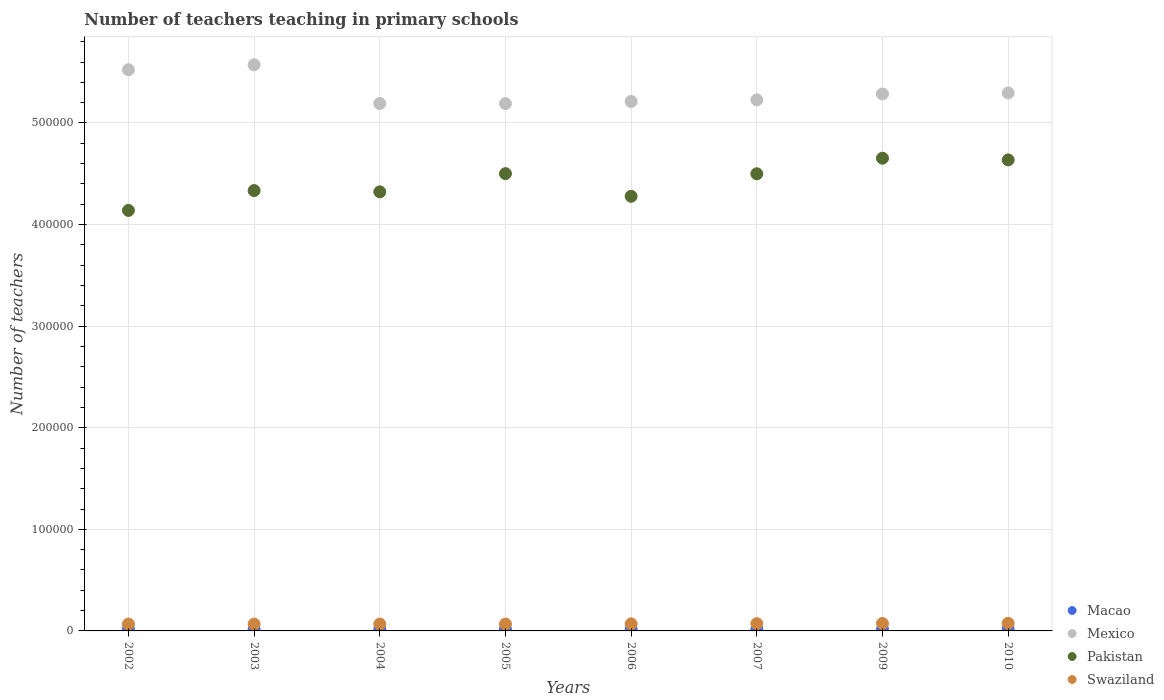How many different coloured dotlines are there?
Offer a terse response. 4. What is the number of teachers teaching in primary schools in Swaziland in 2004?
Provide a succinct answer. 6758. Across all years, what is the maximum number of teachers teaching in primary schools in Pakistan?
Your response must be concise. 4.65e+05. Across all years, what is the minimum number of teachers teaching in primary schools in Mexico?
Provide a short and direct response. 5.19e+05. In which year was the number of teachers teaching in primary schools in Mexico minimum?
Provide a short and direct response. 2005. What is the total number of teachers teaching in primary schools in Swaziland in the graph?
Your response must be concise. 5.58e+04. What is the difference between the number of teachers teaching in primary schools in Macao in 2002 and that in 2006?
Provide a succinct answer. -1. What is the difference between the number of teachers teaching in primary schools in Swaziland in 2006 and the number of teachers teaching in primary schools in Mexico in 2010?
Make the answer very short. -5.23e+05. What is the average number of teachers teaching in primary schools in Swaziland per year?
Provide a short and direct response. 6969.25. In the year 2007, what is the difference between the number of teachers teaching in primary schools in Macao and number of teachers teaching in primary schools in Swaziland?
Provide a short and direct response. -5551. What is the ratio of the number of teachers teaching in primary schools in Swaziland in 2004 to that in 2006?
Ensure brevity in your answer.  0.98. Is the number of teachers teaching in primary schools in Swaziland in 2003 less than that in 2006?
Your response must be concise. Yes. Is the difference between the number of teachers teaching in primary schools in Macao in 2005 and 2007 greater than the difference between the number of teachers teaching in primary schools in Swaziland in 2005 and 2007?
Your answer should be compact. Yes. What is the difference between the highest and the second highest number of teachers teaching in primary schools in Swaziland?
Offer a terse response. 153. What is the difference between the highest and the lowest number of teachers teaching in primary schools in Pakistan?
Keep it short and to the point. 5.14e+04. Is the sum of the number of teachers teaching in primary schools in Pakistan in 2005 and 2007 greater than the maximum number of teachers teaching in primary schools in Macao across all years?
Give a very brief answer. Yes. Is it the case that in every year, the sum of the number of teachers teaching in primary schools in Macao and number of teachers teaching in primary schools in Swaziland  is greater than the sum of number of teachers teaching in primary schools in Mexico and number of teachers teaching in primary schools in Pakistan?
Your answer should be very brief. No. Is it the case that in every year, the sum of the number of teachers teaching in primary schools in Pakistan and number of teachers teaching in primary schools in Mexico  is greater than the number of teachers teaching in primary schools in Swaziland?
Your response must be concise. Yes. Does the number of teachers teaching in primary schools in Mexico monotonically increase over the years?
Your response must be concise. No. Is the number of teachers teaching in primary schools in Pakistan strictly less than the number of teachers teaching in primary schools in Swaziland over the years?
Offer a terse response. No. How many dotlines are there?
Provide a short and direct response. 4. What is the difference between two consecutive major ticks on the Y-axis?
Give a very brief answer. 1.00e+05. Does the graph contain any zero values?
Provide a succinct answer. No. How are the legend labels stacked?
Ensure brevity in your answer.  Vertical. What is the title of the graph?
Provide a succinct answer. Number of teachers teaching in primary schools. Does "Japan" appear as one of the legend labels in the graph?
Your answer should be very brief. No. What is the label or title of the X-axis?
Provide a short and direct response. Years. What is the label or title of the Y-axis?
Make the answer very short. Number of teachers. What is the Number of teachers of Macao in 2002?
Your answer should be very brief. 1616. What is the Number of teachers in Mexico in 2002?
Keep it short and to the point. 5.52e+05. What is the Number of teachers of Pakistan in 2002?
Your answer should be very brief. 4.14e+05. What is the Number of teachers in Swaziland in 2002?
Ensure brevity in your answer.  6727. What is the Number of teachers in Macao in 2003?
Offer a terse response. 1615. What is the Number of teachers in Mexico in 2003?
Offer a very short reply. 5.57e+05. What is the Number of teachers in Pakistan in 2003?
Your answer should be compact. 4.33e+05. What is the Number of teachers in Swaziland in 2003?
Make the answer very short. 6680. What is the Number of teachers of Macao in 2004?
Keep it short and to the point. 1632. What is the Number of teachers in Mexico in 2004?
Offer a terse response. 5.19e+05. What is the Number of teachers of Pakistan in 2004?
Give a very brief answer. 4.32e+05. What is the Number of teachers of Swaziland in 2004?
Your answer should be compact. 6758. What is the Number of teachers in Macao in 2005?
Give a very brief answer. 1609. What is the Number of teachers of Mexico in 2005?
Offer a very short reply. 5.19e+05. What is the Number of teachers in Pakistan in 2005?
Give a very brief answer. 4.50e+05. What is the Number of teachers of Swaziland in 2005?
Provide a short and direct response. 6741. What is the Number of teachers of Macao in 2006?
Offer a very short reply. 1617. What is the Number of teachers in Mexico in 2006?
Offer a terse response. 5.21e+05. What is the Number of teachers in Pakistan in 2006?
Offer a terse response. 4.28e+05. What is the Number of teachers in Swaziland in 2006?
Ensure brevity in your answer.  6906. What is the Number of teachers of Macao in 2007?
Offer a very short reply. 1618. What is the Number of teachers of Mexico in 2007?
Ensure brevity in your answer.  5.23e+05. What is the Number of teachers in Pakistan in 2007?
Your response must be concise. 4.50e+05. What is the Number of teachers of Swaziland in 2007?
Ensure brevity in your answer.  7169. What is the Number of teachers of Macao in 2009?
Your answer should be very brief. 1585. What is the Number of teachers of Mexico in 2009?
Make the answer very short. 5.29e+05. What is the Number of teachers of Pakistan in 2009?
Keep it short and to the point. 4.65e+05. What is the Number of teachers of Swaziland in 2009?
Ensure brevity in your answer.  7310. What is the Number of teachers of Macao in 2010?
Keep it short and to the point. 1577. What is the Number of teachers in Mexico in 2010?
Your answer should be compact. 5.30e+05. What is the Number of teachers of Pakistan in 2010?
Keep it short and to the point. 4.64e+05. What is the Number of teachers in Swaziland in 2010?
Provide a succinct answer. 7463. Across all years, what is the maximum Number of teachers of Macao?
Offer a terse response. 1632. Across all years, what is the maximum Number of teachers in Mexico?
Offer a terse response. 5.57e+05. Across all years, what is the maximum Number of teachers of Pakistan?
Your answer should be very brief. 4.65e+05. Across all years, what is the maximum Number of teachers of Swaziland?
Your answer should be compact. 7463. Across all years, what is the minimum Number of teachers in Macao?
Provide a succinct answer. 1577. Across all years, what is the minimum Number of teachers in Mexico?
Offer a very short reply. 5.19e+05. Across all years, what is the minimum Number of teachers in Pakistan?
Provide a succinct answer. 4.14e+05. Across all years, what is the minimum Number of teachers of Swaziland?
Offer a terse response. 6680. What is the total Number of teachers in Macao in the graph?
Ensure brevity in your answer.  1.29e+04. What is the total Number of teachers of Mexico in the graph?
Your answer should be compact. 4.25e+06. What is the total Number of teachers of Pakistan in the graph?
Your response must be concise. 3.54e+06. What is the total Number of teachers of Swaziland in the graph?
Offer a terse response. 5.58e+04. What is the difference between the Number of teachers in Macao in 2002 and that in 2003?
Your response must be concise. 1. What is the difference between the Number of teachers in Mexico in 2002 and that in 2003?
Your answer should be very brief. -4869. What is the difference between the Number of teachers in Pakistan in 2002 and that in 2003?
Make the answer very short. -1.95e+04. What is the difference between the Number of teachers in Mexico in 2002 and that in 2004?
Offer a very short reply. 3.32e+04. What is the difference between the Number of teachers of Pakistan in 2002 and that in 2004?
Ensure brevity in your answer.  -1.83e+04. What is the difference between the Number of teachers of Swaziland in 2002 and that in 2004?
Your answer should be very brief. -31. What is the difference between the Number of teachers in Macao in 2002 and that in 2005?
Provide a short and direct response. 7. What is the difference between the Number of teachers in Mexico in 2002 and that in 2005?
Keep it short and to the point. 3.33e+04. What is the difference between the Number of teachers of Pakistan in 2002 and that in 2005?
Give a very brief answer. -3.62e+04. What is the difference between the Number of teachers in Mexico in 2002 and that in 2006?
Your answer should be compact. 3.12e+04. What is the difference between the Number of teachers of Pakistan in 2002 and that in 2006?
Make the answer very short. -1.39e+04. What is the difference between the Number of teachers in Swaziland in 2002 and that in 2006?
Ensure brevity in your answer.  -179. What is the difference between the Number of teachers in Mexico in 2002 and that in 2007?
Provide a short and direct response. 2.97e+04. What is the difference between the Number of teachers of Pakistan in 2002 and that in 2007?
Offer a very short reply. -3.61e+04. What is the difference between the Number of teachers of Swaziland in 2002 and that in 2007?
Ensure brevity in your answer.  -442. What is the difference between the Number of teachers of Mexico in 2002 and that in 2009?
Your answer should be very brief. 2.39e+04. What is the difference between the Number of teachers in Pakistan in 2002 and that in 2009?
Give a very brief answer. -5.14e+04. What is the difference between the Number of teachers in Swaziland in 2002 and that in 2009?
Offer a very short reply. -583. What is the difference between the Number of teachers in Macao in 2002 and that in 2010?
Your answer should be compact. 39. What is the difference between the Number of teachers of Mexico in 2002 and that in 2010?
Your answer should be very brief. 2.28e+04. What is the difference between the Number of teachers of Pakistan in 2002 and that in 2010?
Provide a short and direct response. -4.98e+04. What is the difference between the Number of teachers of Swaziland in 2002 and that in 2010?
Your answer should be very brief. -736. What is the difference between the Number of teachers of Mexico in 2003 and that in 2004?
Offer a terse response. 3.81e+04. What is the difference between the Number of teachers in Pakistan in 2003 and that in 2004?
Provide a succinct answer. 1239. What is the difference between the Number of teachers of Swaziland in 2003 and that in 2004?
Offer a terse response. -78. What is the difference between the Number of teachers of Macao in 2003 and that in 2005?
Your answer should be compact. 6. What is the difference between the Number of teachers of Mexico in 2003 and that in 2005?
Ensure brevity in your answer.  3.82e+04. What is the difference between the Number of teachers in Pakistan in 2003 and that in 2005?
Provide a short and direct response. -1.67e+04. What is the difference between the Number of teachers in Swaziland in 2003 and that in 2005?
Give a very brief answer. -61. What is the difference between the Number of teachers in Macao in 2003 and that in 2006?
Give a very brief answer. -2. What is the difference between the Number of teachers of Mexico in 2003 and that in 2006?
Your answer should be very brief. 3.61e+04. What is the difference between the Number of teachers in Pakistan in 2003 and that in 2006?
Make the answer very short. 5631. What is the difference between the Number of teachers of Swaziland in 2003 and that in 2006?
Your response must be concise. -226. What is the difference between the Number of teachers in Macao in 2003 and that in 2007?
Your response must be concise. -3. What is the difference between the Number of teachers in Mexico in 2003 and that in 2007?
Provide a short and direct response. 3.45e+04. What is the difference between the Number of teachers of Pakistan in 2003 and that in 2007?
Offer a very short reply. -1.66e+04. What is the difference between the Number of teachers in Swaziland in 2003 and that in 2007?
Your response must be concise. -489. What is the difference between the Number of teachers of Macao in 2003 and that in 2009?
Give a very brief answer. 30. What is the difference between the Number of teachers of Mexico in 2003 and that in 2009?
Provide a succinct answer. 2.87e+04. What is the difference between the Number of teachers in Pakistan in 2003 and that in 2009?
Your response must be concise. -3.19e+04. What is the difference between the Number of teachers in Swaziland in 2003 and that in 2009?
Ensure brevity in your answer.  -630. What is the difference between the Number of teachers in Mexico in 2003 and that in 2010?
Provide a short and direct response. 2.77e+04. What is the difference between the Number of teachers of Pakistan in 2003 and that in 2010?
Offer a very short reply. -3.02e+04. What is the difference between the Number of teachers in Swaziland in 2003 and that in 2010?
Offer a very short reply. -783. What is the difference between the Number of teachers in Macao in 2004 and that in 2005?
Keep it short and to the point. 23. What is the difference between the Number of teachers of Mexico in 2004 and that in 2005?
Provide a short and direct response. 49. What is the difference between the Number of teachers in Pakistan in 2004 and that in 2005?
Keep it short and to the point. -1.79e+04. What is the difference between the Number of teachers of Swaziland in 2004 and that in 2005?
Offer a terse response. 17. What is the difference between the Number of teachers in Macao in 2004 and that in 2006?
Your response must be concise. 15. What is the difference between the Number of teachers of Mexico in 2004 and that in 2006?
Offer a very short reply. -2022. What is the difference between the Number of teachers of Pakistan in 2004 and that in 2006?
Your answer should be very brief. 4392. What is the difference between the Number of teachers of Swaziland in 2004 and that in 2006?
Give a very brief answer. -148. What is the difference between the Number of teachers of Macao in 2004 and that in 2007?
Your answer should be very brief. 14. What is the difference between the Number of teachers of Mexico in 2004 and that in 2007?
Make the answer very short. -3572. What is the difference between the Number of teachers in Pakistan in 2004 and that in 2007?
Your answer should be compact. -1.78e+04. What is the difference between the Number of teachers in Swaziland in 2004 and that in 2007?
Provide a succinct answer. -411. What is the difference between the Number of teachers in Mexico in 2004 and that in 2009?
Make the answer very short. -9394. What is the difference between the Number of teachers in Pakistan in 2004 and that in 2009?
Your response must be concise. -3.31e+04. What is the difference between the Number of teachers in Swaziland in 2004 and that in 2009?
Your answer should be compact. -552. What is the difference between the Number of teachers in Mexico in 2004 and that in 2010?
Make the answer very short. -1.04e+04. What is the difference between the Number of teachers in Pakistan in 2004 and that in 2010?
Offer a very short reply. -3.15e+04. What is the difference between the Number of teachers in Swaziland in 2004 and that in 2010?
Your answer should be very brief. -705. What is the difference between the Number of teachers of Mexico in 2005 and that in 2006?
Ensure brevity in your answer.  -2071. What is the difference between the Number of teachers in Pakistan in 2005 and that in 2006?
Provide a succinct answer. 2.23e+04. What is the difference between the Number of teachers in Swaziland in 2005 and that in 2006?
Your answer should be very brief. -165. What is the difference between the Number of teachers of Mexico in 2005 and that in 2007?
Your answer should be very brief. -3621. What is the difference between the Number of teachers in Pakistan in 2005 and that in 2007?
Provide a short and direct response. 109. What is the difference between the Number of teachers in Swaziland in 2005 and that in 2007?
Offer a terse response. -428. What is the difference between the Number of teachers of Mexico in 2005 and that in 2009?
Make the answer very short. -9443. What is the difference between the Number of teachers in Pakistan in 2005 and that in 2009?
Your response must be concise. -1.52e+04. What is the difference between the Number of teachers in Swaziland in 2005 and that in 2009?
Your answer should be very brief. -569. What is the difference between the Number of teachers in Mexico in 2005 and that in 2010?
Give a very brief answer. -1.05e+04. What is the difference between the Number of teachers in Pakistan in 2005 and that in 2010?
Your answer should be very brief. -1.35e+04. What is the difference between the Number of teachers in Swaziland in 2005 and that in 2010?
Your answer should be compact. -722. What is the difference between the Number of teachers in Mexico in 2006 and that in 2007?
Provide a succinct answer. -1550. What is the difference between the Number of teachers in Pakistan in 2006 and that in 2007?
Make the answer very short. -2.22e+04. What is the difference between the Number of teachers of Swaziland in 2006 and that in 2007?
Offer a terse response. -263. What is the difference between the Number of teachers of Mexico in 2006 and that in 2009?
Offer a terse response. -7372. What is the difference between the Number of teachers of Pakistan in 2006 and that in 2009?
Provide a succinct answer. -3.75e+04. What is the difference between the Number of teachers of Swaziland in 2006 and that in 2009?
Offer a terse response. -404. What is the difference between the Number of teachers in Macao in 2006 and that in 2010?
Your answer should be very brief. 40. What is the difference between the Number of teachers in Mexico in 2006 and that in 2010?
Your answer should be compact. -8416. What is the difference between the Number of teachers in Pakistan in 2006 and that in 2010?
Ensure brevity in your answer.  -3.58e+04. What is the difference between the Number of teachers of Swaziland in 2006 and that in 2010?
Your response must be concise. -557. What is the difference between the Number of teachers in Macao in 2007 and that in 2009?
Offer a terse response. 33. What is the difference between the Number of teachers of Mexico in 2007 and that in 2009?
Your answer should be compact. -5822. What is the difference between the Number of teachers of Pakistan in 2007 and that in 2009?
Provide a succinct answer. -1.53e+04. What is the difference between the Number of teachers of Swaziland in 2007 and that in 2009?
Ensure brevity in your answer.  -141. What is the difference between the Number of teachers in Macao in 2007 and that in 2010?
Your answer should be compact. 41. What is the difference between the Number of teachers in Mexico in 2007 and that in 2010?
Provide a succinct answer. -6866. What is the difference between the Number of teachers in Pakistan in 2007 and that in 2010?
Offer a terse response. -1.36e+04. What is the difference between the Number of teachers of Swaziland in 2007 and that in 2010?
Provide a short and direct response. -294. What is the difference between the Number of teachers of Macao in 2009 and that in 2010?
Ensure brevity in your answer.  8. What is the difference between the Number of teachers in Mexico in 2009 and that in 2010?
Offer a very short reply. -1044. What is the difference between the Number of teachers in Pakistan in 2009 and that in 2010?
Offer a terse response. 1660. What is the difference between the Number of teachers in Swaziland in 2009 and that in 2010?
Your answer should be compact. -153. What is the difference between the Number of teachers in Macao in 2002 and the Number of teachers in Mexico in 2003?
Provide a succinct answer. -5.56e+05. What is the difference between the Number of teachers of Macao in 2002 and the Number of teachers of Pakistan in 2003?
Ensure brevity in your answer.  -4.32e+05. What is the difference between the Number of teachers in Macao in 2002 and the Number of teachers in Swaziland in 2003?
Make the answer very short. -5064. What is the difference between the Number of teachers of Mexico in 2002 and the Number of teachers of Pakistan in 2003?
Your answer should be compact. 1.19e+05. What is the difference between the Number of teachers of Mexico in 2002 and the Number of teachers of Swaziland in 2003?
Your answer should be very brief. 5.46e+05. What is the difference between the Number of teachers of Pakistan in 2002 and the Number of teachers of Swaziland in 2003?
Your response must be concise. 4.07e+05. What is the difference between the Number of teachers in Macao in 2002 and the Number of teachers in Mexico in 2004?
Your answer should be compact. -5.18e+05. What is the difference between the Number of teachers in Macao in 2002 and the Number of teachers in Pakistan in 2004?
Offer a terse response. -4.31e+05. What is the difference between the Number of teachers in Macao in 2002 and the Number of teachers in Swaziland in 2004?
Make the answer very short. -5142. What is the difference between the Number of teachers of Mexico in 2002 and the Number of teachers of Pakistan in 2004?
Your answer should be very brief. 1.20e+05. What is the difference between the Number of teachers of Mexico in 2002 and the Number of teachers of Swaziland in 2004?
Your answer should be compact. 5.46e+05. What is the difference between the Number of teachers of Pakistan in 2002 and the Number of teachers of Swaziland in 2004?
Your answer should be compact. 4.07e+05. What is the difference between the Number of teachers in Macao in 2002 and the Number of teachers in Mexico in 2005?
Give a very brief answer. -5.17e+05. What is the difference between the Number of teachers in Macao in 2002 and the Number of teachers in Pakistan in 2005?
Your answer should be compact. -4.49e+05. What is the difference between the Number of teachers in Macao in 2002 and the Number of teachers in Swaziland in 2005?
Make the answer very short. -5125. What is the difference between the Number of teachers in Mexico in 2002 and the Number of teachers in Pakistan in 2005?
Your answer should be very brief. 1.02e+05. What is the difference between the Number of teachers in Mexico in 2002 and the Number of teachers in Swaziland in 2005?
Provide a succinct answer. 5.46e+05. What is the difference between the Number of teachers of Pakistan in 2002 and the Number of teachers of Swaziland in 2005?
Your answer should be compact. 4.07e+05. What is the difference between the Number of teachers of Macao in 2002 and the Number of teachers of Mexico in 2006?
Ensure brevity in your answer.  -5.20e+05. What is the difference between the Number of teachers in Macao in 2002 and the Number of teachers in Pakistan in 2006?
Ensure brevity in your answer.  -4.26e+05. What is the difference between the Number of teachers in Macao in 2002 and the Number of teachers in Swaziland in 2006?
Your answer should be very brief. -5290. What is the difference between the Number of teachers of Mexico in 2002 and the Number of teachers of Pakistan in 2006?
Your answer should be compact. 1.25e+05. What is the difference between the Number of teachers in Mexico in 2002 and the Number of teachers in Swaziland in 2006?
Your answer should be very brief. 5.46e+05. What is the difference between the Number of teachers in Pakistan in 2002 and the Number of teachers in Swaziland in 2006?
Provide a succinct answer. 4.07e+05. What is the difference between the Number of teachers in Macao in 2002 and the Number of teachers in Mexico in 2007?
Provide a short and direct response. -5.21e+05. What is the difference between the Number of teachers in Macao in 2002 and the Number of teachers in Pakistan in 2007?
Your response must be concise. -4.48e+05. What is the difference between the Number of teachers in Macao in 2002 and the Number of teachers in Swaziland in 2007?
Ensure brevity in your answer.  -5553. What is the difference between the Number of teachers of Mexico in 2002 and the Number of teachers of Pakistan in 2007?
Keep it short and to the point. 1.02e+05. What is the difference between the Number of teachers in Mexico in 2002 and the Number of teachers in Swaziland in 2007?
Offer a very short reply. 5.45e+05. What is the difference between the Number of teachers in Pakistan in 2002 and the Number of teachers in Swaziland in 2007?
Offer a very short reply. 4.07e+05. What is the difference between the Number of teachers in Macao in 2002 and the Number of teachers in Mexico in 2009?
Offer a terse response. -5.27e+05. What is the difference between the Number of teachers of Macao in 2002 and the Number of teachers of Pakistan in 2009?
Provide a short and direct response. -4.64e+05. What is the difference between the Number of teachers of Macao in 2002 and the Number of teachers of Swaziland in 2009?
Make the answer very short. -5694. What is the difference between the Number of teachers in Mexico in 2002 and the Number of teachers in Pakistan in 2009?
Provide a short and direct response. 8.71e+04. What is the difference between the Number of teachers of Mexico in 2002 and the Number of teachers of Swaziland in 2009?
Ensure brevity in your answer.  5.45e+05. What is the difference between the Number of teachers of Pakistan in 2002 and the Number of teachers of Swaziland in 2009?
Your answer should be compact. 4.07e+05. What is the difference between the Number of teachers in Macao in 2002 and the Number of teachers in Mexico in 2010?
Give a very brief answer. -5.28e+05. What is the difference between the Number of teachers of Macao in 2002 and the Number of teachers of Pakistan in 2010?
Offer a very short reply. -4.62e+05. What is the difference between the Number of teachers in Macao in 2002 and the Number of teachers in Swaziland in 2010?
Provide a succinct answer. -5847. What is the difference between the Number of teachers in Mexico in 2002 and the Number of teachers in Pakistan in 2010?
Give a very brief answer. 8.87e+04. What is the difference between the Number of teachers of Mexico in 2002 and the Number of teachers of Swaziland in 2010?
Keep it short and to the point. 5.45e+05. What is the difference between the Number of teachers of Pakistan in 2002 and the Number of teachers of Swaziland in 2010?
Offer a terse response. 4.06e+05. What is the difference between the Number of teachers of Macao in 2003 and the Number of teachers of Mexico in 2004?
Ensure brevity in your answer.  -5.18e+05. What is the difference between the Number of teachers of Macao in 2003 and the Number of teachers of Pakistan in 2004?
Your response must be concise. -4.31e+05. What is the difference between the Number of teachers in Macao in 2003 and the Number of teachers in Swaziland in 2004?
Provide a succinct answer. -5143. What is the difference between the Number of teachers of Mexico in 2003 and the Number of teachers of Pakistan in 2004?
Offer a terse response. 1.25e+05. What is the difference between the Number of teachers of Mexico in 2003 and the Number of teachers of Swaziland in 2004?
Your response must be concise. 5.51e+05. What is the difference between the Number of teachers in Pakistan in 2003 and the Number of teachers in Swaziland in 2004?
Offer a terse response. 4.27e+05. What is the difference between the Number of teachers of Macao in 2003 and the Number of teachers of Mexico in 2005?
Your answer should be compact. -5.17e+05. What is the difference between the Number of teachers of Macao in 2003 and the Number of teachers of Pakistan in 2005?
Provide a succinct answer. -4.49e+05. What is the difference between the Number of teachers in Macao in 2003 and the Number of teachers in Swaziland in 2005?
Provide a short and direct response. -5126. What is the difference between the Number of teachers in Mexico in 2003 and the Number of teachers in Pakistan in 2005?
Offer a very short reply. 1.07e+05. What is the difference between the Number of teachers of Mexico in 2003 and the Number of teachers of Swaziland in 2005?
Your answer should be compact. 5.51e+05. What is the difference between the Number of teachers in Pakistan in 2003 and the Number of teachers in Swaziland in 2005?
Make the answer very short. 4.27e+05. What is the difference between the Number of teachers in Macao in 2003 and the Number of teachers in Mexico in 2006?
Your response must be concise. -5.20e+05. What is the difference between the Number of teachers in Macao in 2003 and the Number of teachers in Pakistan in 2006?
Offer a terse response. -4.26e+05. What is the difference between the Number of teachers of Macao in 2003 and the Number of teachers of Swaziland in 2006?
Provide a succinct answer. -5291. What is the difference between the Number of teachers of Mexico in 2003 and the Number of teachers of Pakistan in 2006?
Keep it short and to the point. 1.29e+05. What is the difference between the Number of teachers in Mexico in 2003 and the Number of teachers in Swaziland in 2006?
Keep it short and to the point. 5.50e+05. What is the difference between the Number of teachers in Pakistan in 2003 and the Number of teachers in Swaziland in 2006?
Provide a succinct answer. 4.27e+05. What is the difference between the Number of teachers of Macao in 2003 and the Number of teachers of Mexico in 2007?
Make the answer very short. -5.21e+05. What is the difference between the Number of teachers of Macao in 2003 and the Number of teachers of Pakistan in 2007?
Ensure brevity in your answer.  -4.48e+05. What is the difference between the Number of teachers of Macao in 2003 and the Number of teachers of Swaziland in 2007?
Give a very brief answer. -5554. What is the difference between the Number of teachers in Mexico in 2003 and the Number of teachers in Pakistan in 2007?
Your response must be concise. 1.07e+05. What is the difference between the Number of teachers of Mexico in 2003 and the Number of teachers of Swaziland in 2007?
Keep it short and to the point. 5.50e+05. What is the difference between the Number of teachers in Pakistan in 2003 and the Number of teachers in Swaziland in 2007?
Keep it short and to the point. 4.26e+05. What is the difference between the Number of teachers in Macao in 2003 and the Number of teachers in Mexico in 2009?
Ensure brevity in your answer.  -5.27e+05. What is the difference between the Number of teachers in Macao in 2003 and the Number of teachers in Pakistan in 2009?
Your answer should be compact. -4.64e+05. What is the difference between the Number of teachers of Macao in 2003 and the Number of teachers of Swaziland in 2009?
Your answer should be compact. -5695. What is the difference between the Number of teachers of Mexico in 2003 and the Number of teachers of Pakistan in 2009?
Offer a terse response. 9.19e+04. What is the difference between the Number of teachers in Mexico in 2003 and the Number of teachers in Swaziland in 2009?
Provide a succinct answer. 5.50e+05. What is the difference between the Number of teachers in Pakistan in 2003 and the Number of teachers in Swaziland in 2009?
Your response must be concise. 4.26e+05. What is the difference between the Number of teachers of Macao in 2003 and the Number of teachers of Mexico in 2010?
Offer a very short reply. -5.28e+05. What is the difference between the Number of teachers of Macao in 2003 and the Number of teachers of Pakistan in 2010?
Offer a terse response. -4.62e+05. What is the difference between the Number of teachers of Macao in 2003 and the Number of teachers of Swaziland in 2010?
Give a very brief answer. -5848. What is the difference between the Number of teachers of Mexico in 2003 and the Number of teachers of Pakistan in 2010?
Give a very brief answer. 9.36e+04. What is the difference between the Number of teachers in Mexico in 2003 and the Number of teachers in Swaziland in 2010?
Provide a succinct answer. 5.50e+05. What is the difference between the Number of teachers in Pakistan in 2003 and the Number of teachers in Swaziland in 2010?
Your answer should be compact. 4.26e+05. What is the difference between the Number of teachers of Macao in 2004 and the Number of teachers of Mexico in 2005?
Give a very brief answer. -5.17e+05. What is the difference between the Number of teachers of Macao in 2004 and the Number of teachers of Pakistan in 2005?
Your response must be concise. -4.49e+05. What is the difference between the Number of teachers in Macao in 2004 and the Number of teachers in Swaziland in 2005?
Provide a short and direct response. -5109. What is the difference between the Number of teachers of Mexico in 2004 and the Number of teachers of Pakistan in 2005?
Your answer should be compact. 6.90e+04. What is the difference between the Number of teachers of Mexico in 2004 and the Number of teachers of Swaziland in 2005?
Your answer should be compact. 5.12e+05. What is the difference between the Number of teachers in Pakistan in 2004 and the Number of teachers in Swaziland in 2005?
Offer a terse response. 4.25e+05. What is the difference between the Number of teachers in Macao in 2004 and the Number of teachers in Mexico in 2006?
Give a very brief answer. -5.20e+05. What is the difference between the Number of teachers in Macao in 2004 and the Number of teachers in Pakistan in 2006?
Your answer should be very brief. -4.26e+05. What is the difference between the Number of teachers in Macao in 2004 and the Number of teachers in Swaziland in 2006?
Provide a short and direct response. -5274. What is the difference between the Number of teachers in Mexico in 2004 and the Number of teachers in Pakistan in 2006?
Keep it short and to the point. 9.13e+04. What is the difference between the Number of teachers in Mexico in 2004 and the Number of teachers in Swaziland in 2006?
Give a very brief answer. 5.12e+05. What is the difference between the Number of teachers in Pakistan in 2004 and the Number of teachers in Swaziland in 2006?
Offer a very short reply. 4.25e+05. What is the difference between the Number of teachers in Macao in 2004 and the Number of teachers in Mexico in 2007?
Ensure brevity in your answer.  -5.21e+05. What is the difference between the Number of teachers of Macao in 2004 and the Number of teachers of Pakistan in 2007?
Provide a short and direct response. -4.48e+05. What is the difference between the Number of teachers of Macao in 2004 and the Number of teachers of Swaziland in 2007?
Ensure brevity in your answer.  -5537. What is the difference between the Number of teachers in Mexico in 2004 and the Number of teachers in Pakistan in 2007?
Ensure brevity in your answer.  6.91e+04. What is the difference between the Number of teachers in Mexico in 2004 and the Number of teachers in Swaziland in 2007?
Provide a succinct answer. 5.12e+05. What is the difference between the Number of teachers in Pakistan in 2004 and the Number of teachers in Swaziland in 2007?
Keep it short and to the point. 4.25e+05. What is the difference between the Number of teachers in Macao in 2004 and the Number of teachers in Mexico in 2009?
Provide a short and direct response. -5.27e+05. What is the difference between the Number of teachers in Macao in 2004 and the Number of teachers in Pakistan in 2009?
Provide a short and direct response. -4.64e+05. What is the difference between the Number of teachers in Macao in 2004 and the Number of teachers in Swaziland in 2009?
Make the answer very short. -5678. What is the difference between the Number of teachers of Mexico in 2004 and the Number of teachers of Pakistan in 2009?
Ensure brevity in your answer.  5.38e+04. What is the difference between the Number of teachers of Mexico in 2004 and the Number of teachers of Swaziland in 2009?
Your answer should be compact. 5.12e+05. What is the difference between the Number of teachers in Pakistan in 2004 and the Number of teachers in Swaziland in 2009?
Keep it short and to the point. 4.25e+05. What is the difference between the Number of teachers in Macao in 2004 and the Number of teachers in Mexico in 2010?
Keep it short and to the point. -5.28e+05. What is the difference between the Number of teachers of Macao in 2004 and the Number of teachers of Pakistan in 2010?
Ensure brevity in your answer.  -4.62e+05. What is the difference between the Number of teachers in Macao in 2004 and the Number of teachers in Swaziland in 2010?
Provide a short and direct response. -5831. What is the difference between the Number of teachers of Mexico in 2004 and the Number of teachers of Pakistan in 2010?
Offer a terse response. 5.55e+04. What is the difference between the Number of teachers of Mexico in 2004 and the Number of teachers of Swaziland in 2010?
Give a very brief answer. 5.12e+05. What is the difference between the Number of teachers in Pakistan in 2004 and the Number of teachers in Swaziland in 2010?
Make the answer very short. 4.25e+05. What is the difference between the Number of teachers of Macao in 2005 and the Number of teachers of Mexico in 2006?
Keep it short and to the point. -5.20e+05. What is the difference between the Number of teachers in Macao in 2005 and the Number of teachers in Pakistan in 2006?
Your answer should be compact. -4.26e+05. What is the difference between the Number of teachers in Macao in 2005 and the Number of teachers in Swaziland in 2006?
Your answer should be compact. -5297. What is the difference between the Number of teachers in Mexico in 2005 and the Number of teachers in Pakistan in 2006?
Give a very brief answer. 9.13e+04. What is the difference between the Number of teachers of Mexico in 2005 and the Number of teachers of Swaziland in 2006?
Keep it short and to the point. 5.12e+05. What is the difference between the Number of teachers in Pakistan in 2005 and the Number of teachers in Swaziland in 2006?
Give a very brief answer. 4.43e+05. What is the difference between the Number of teachers of Macao in 2005 and the Number of teachers of Mexico in 2007?
Ensure brevity in your answer.  -5.21e+05. What is the difference between the Number of teachers of Macao in 2005 and the Number of teachers of Pakistan in 2007?
Ensure brevity in your answer.  -4.48e+05. What is the difference between the Number of teachers in Macao in 2005 and the Number of teachers in Swaziland in 2007?
Give a very brief answer. -5560. What is the difference between the Number of teachers of Mexico in 2005 and the Number of teachers of Pakistan in 2007?
Your response must be concise. 6.91e+04. What is the difference between the Number of teachers in Mexico in 2005 and the Number of teachers in Swaziland in 2007?
Keep it short and to the point. 5.12e+05. What is the difference between the Number of teachers in Pakistan in 2005 and the Number of teachers in Swaziland in 2007?
Provide a succinct answer. 4.43e+05. What is the difference between the Number of teachers of Macao in 2005 and the Number of teachers of Mexico in 2009?
Offer a terse response. -5.27e+05. What is the difference between the Number of teachers of Macao in 2005 and the Number of teachers of Pakistan in 2009?
Your answer should be very brief. -4.64e+05. What is the difference between the Number of teachers of Macao in 2005 and the Number of teachers of Swaziland in 2009?
Your answer should be very brief. -5701. What is the difference between the Number of teachers in Mexico in 2005 and the Number of teachers in Pakistan in 2009?
Give a very brief answer. 5.38e+04. What is the difference between the Number of teachers in Mexico in 2005 and the Number of teachers in Swaziland in 2009?
Give a very brief answer. 5.12e+05. What is the difference between the Number of teachers of Pakistan in 2005 and the Number of teachers of Swaziland in 2009?
Offer a very short reply. 4.43e+05. What is the difference between the Number of teachers in Macao in 2005 and the Number of teachers in Mexico in 2010?
Provide a succinct answer. -5.28e+05. What is the difference between the Number of teachers of Macao in 2005 and the Number of teachers of Pakistan in 2010?
Offer a terse response. -4.62e+05. What is the difference between the Number of teachers in Macao in 2005 and the Number of teachers in Swaziland in 2010?
Offer a terse response. -5854. What is the difference between the Number of teachers in Mexico in 2005 and the Number of teachers in Pakistan in 2010?
Your response must be concise. 5.54e+04. What is the difference between the Number of teachers of Mexico in 2005 and the Number of teachers of Swaziland in 2010?
Provide a short and direct response. 5.12e+05. What is the difference between the Number of teachers of Pakistan in 2005 and the Number of teachers of Swaziland in 2010?
Provide a short and direct response. 4.43e+05. What is the difference between the Number of teachers in Macao in 2006 and the Number of teachers in Mexico in 2007?
Your response must be concise. -5.21e+05. What is the difference between the Number of teachers in Macao in 2006 and the Number of teachers in Pakistan in 2007?
Offer a terse response. -4.48e+05. What is the difference between the Number of teachers in Macao in 2006 and the Number of teachers in Swaziland in 2007?
Make the answer very short. -5552. What is the difference between the Number of teachers in Mexico in 2006 and the Number of teachers in Pakistan in 2007?
Make the answer very short. 7.12e+04. What is the difference between the Number of teachers of Mexico in 2006 and the Number of teachers of Swaziland in 2007?
Ensure brevity in your answer.  5.14e+05. What is the difference between the Number of teachers in Pakistan in 2006 and the Number of teachers in Swaziland in 2007?
Your answer should be very brief. 4.21e+05. What is the difference between the Number of teachers in Macao in 2006 and the Number of teachers in Mexico in 2009?
Give a very brief answer. -5.27e+05. What is the difference between the Number of teachers of Macao in 2006 and the Number of teachers of Pakistan in 2009?
Provide a short and direct response. -4.64e+05. What is the difference between the Number of teachers in Macao in 2006 and the Number of teachers in Swaziland in 2009?
Make the answer very short. -5693. What is the difference between the Number of teachers of Mexico in 2006 and the Number of teachers of Pakistan in 2009?
Offer a terse response. 5.58e+04. What is the difference between the Number of teachers in Mexico in 2006 and the Number of teachers in Swaziland in 2009?
Provide a short and direct response. 5.14e+05. What is the difference between the Number of teachers in Pakistan in 2006 and the Number of teachers in Swaziland in 2009?
Your answer should be compact. 4.21e+05. What is the difference between the Number of teachers in Macao in 2006 and the Number of teachers in Mexico in 2010?
Your answer should be very brief. -5.28e+05. What is the difference between the Number of teachers in Macao in 2006 and the Number of teachers in Pakistan in 2010?
Give a very brief answer. -4.62e+05. What is the difference between the Number of teachers of Macao in 2006 and the Number of teachers of Swaziland in 2010?
Offer a very short reply. -5846. What is the difference between the Number of teachers of Mexico in 2006 and the Number of teachers of Pakistan in 2010?
Ensure brevity in your answer.  5.75e+04. What is the difference between the Number of teachers in Mexico in 2006 and the Number of teachers in Swaziland in 2010?
Your answer should be compact. 5.14e+05. What is the difference between the Number of teachers of Pakistan in 2006 and the Number of teachers of Swaziland in 2010?
Offer a terse response. 4.20e+05. What is the difference between the Number of teachers in Macao in 2007 and the Number of teachers in Mexico in 2009?
Give a very brief answer. -5.27e+05. What is the difference between the Number of teachers in Macao in 2007 and the Number of teachers in Pakistan in 2009?
Offer a terse response. -4.64e+05. What is the difference between the Number of teachers in Macao in 2007 and the Number of teachers in Swaziland in 2009?
Make the answer very short. -5692. What is the difference between the Number of teachers of Mexico in 2007 and the Number of teachers of Pakistan in 2009?
Keep it short and to the point. 5.74e+04. What is the difference between the Number of teachers of Mexico in 2007 and the Number of teachers of Swaziland in 2009?
Make the answer very short. 5.15e+05. What is the difference between the Number of teachers of Pakistan in 2007 and the Number of teachers of Swaziland in 2009?
Provide a short and direct response. 4.43e+05. What is the difference between the Number of teachers of Macao in 2007 and the Number of teachers of Mexico in 2010?
Offer a terse response. -5.28e+05. What is the difference between the Number of teachers of Macao in 2007 and the Number of teachers of Pakistan in 2010?
Your answer should be compact. -4.62e+05. What is the difference between the Number of teachers in Macao in 2007 and the Number of teachers in Swaziland in 2010?
Provide a short and direct response. -5845. What is the difference between the Number of teachers of Mexico in 2007 and the Number of teachers of Pakistan in 2010?
Your response must be concise. 5.91e+04. What is the difference between the Number of teachers of Mexico in 2007 and the Number of teachers of Swaziland in 2010?
Provide a succinct answer. 5.15e+05. What is the difference between the Number of teachers of Pakistan in 2007 and the Number of teachers of Swaziland in 2010?
Keep it short and to the point. 4.43e+05. What is the difference between the Number of teachers in Macao in 2009 and the Number of teachers in Mexico in 2010?
Your answer should be compact. -5.28e+05. What is the difference between the Number of teachers of Macao in 2009 and the Number of teachers of Pakistan in 2010?
Your answer should be compact. -4.62e+05. What is the difference between the Number of teachers of Macao in 2009 and the Number of teachers of Swaziland in 2010?
Offer a terse response. -5878. What is the difference between the Number of teachers of Mexico in 2009 and the Number of teachers of Pakistan in 2010?
Keep it short and to the point. 6.49e+04. What is the difference between the Number of teachers of Mexico in 2009 and the Number of teachers of Swaziland in 2010?
Your response must be concise. 5.21e+05. What is the difference between the Number of teachers of Pakistan in 2009 and the Number of teachers of Swaziland in 2010?
Your answer should be very brief. 4.58e+05. What is the average Number of teachers in Macao per year?
Provide a succinct answer. 1608.62. What is the average Number of teachers of Mexico per year?
Make the answer very short. 5.31e+05. What is the average Number of teachers of Pakistan per year?
Provide a succinct answer. 4.42e+05. What is the average Number of teachers in Swaziland per year?
Provide a succinct answer. 6969.25. In the year 2002, what is the difference between the Number of teachers of Macao and Number of teachers of Mexico?
Make the answer very short. -5.51e+05. In the year 2002, what is the difference between the Number of teachers in Macao and Number of teachers in Pakistan?
Your answer should be very brief. -4.12e+05. In the year 2002, what is the difference between the Number of teachers in Macao and Number of teachers in Swaziland?
Provide a short and direct response. -5111. In the year 2002, what is the difference between the Number of teachers of Mexico and Number of teachers of Pakistan?
Ensure brevity in your answer.  1.38e+05. In the year 2002, what is the difference between the Number of teachers in Mexico and Number of teachers in Swaziland?
Your response must be concise. 5.46e+05. In the year 2002, what is the difference between the Number of teachers of Pakistan and Number of teachers of Swaziland?
Make the answer very short. 4.07e+05. In the year 2003, what is the difference between the Number of teachers in Macao and Number of teachers in Mexico?
Ensure brevity in your answer.  -5.56e+05. In the year 2003, what is the difference between the Number of teachers of Macao and Number of teachers of Pakistan?
Your answer should be very brief. -4.32e+05. In the year 2003, what is the difference between the Number of teachers of Macao and Number of teachers of Swaziland?
Keep it short and to the point. -5065. In the year 2003, what is the difference between the Number of teachers of Mexico and Number of teachers of Pakistan?
Your response must be concise. 1.24e+05. In the year 2003, what is the difference between the Number of teachers in Mexico and Number of teachers in Swaziland?
Your answer should be compact. 5.51e+05. In the year 2003, what is the difference between the Number of teachers of Pakistan and Number of teachers of Swaziland?
Your response must be concise. 4.27e+05. In the year 2004, what is the difference between the Number of teachers of Macao and Number of teachers of Mexico?
Keep it short and to the point. -5.18e+05. In the year 2004, what is the difference between the Number of teachers of Macao and Number of teachers of Pakistan?
Provide a succinct answer. -4.31e+05. In the year 2004, what is the difference between the Number of teachers of Macao and Number of teachers of Swaziland?
Your answer should be compact. -5126. In the year 2004, what is the difference between the Number of teachers of Mexico and Number of teachers of Pakistan?
Give a very brief answer. 8.69e+04. In the year 2004, what is the difference between the Number of teachers in Mexico and Number of teachers in Swaziland?
Your response must be concise. 5.12e+05. In the year 2004, what is the difference between the Number of teachers in Pakistan and Number of teachers in Swaziland?
Provide a short and direct response. 4.25e+05. In the year 2005, what is the difference between the Number of teachers of Macao and Number of teachers of Mexico?
Provide a succinct answer. -5.18e+05. In the year 2005, what is the difference between the Number of teachers in Macao and Number of teachers in Pakistan?
Give a very brief answer. -4.49e+05. In the year 2005, what is the difference between the Number of teachers of Macao and Number of teachers of Swaziland?
Offer a terse response. -5132. In the year 2005, what is the difference between the Number of teachers of Mexico and Number of teachers of Pakistan?
Give a very brief answer. 6.90e+04. In the year 2005, what is the difference between the Number of teachers in Mexico and Number of teachers in Swaziland?
Your response must be concise. 5.12e+05. In the year 2005, what is the difference between the Number of teachers in Pakistan and Number of teachers in Swaziland?
Your answer should be compact. 4.43e+05. In the year 2006, what is the difference between the Number of teachers of Macao and Number of teachers of Mexico?
Provide a short and direct response. -5.20e+05. In the year 2006, what is the difference between the Number of teachers in Macao and Number of teachers in Pakistan?
Give a very brief answer. -4.26e+05. In the year 2006, what is the difference between the Number of teachers of Macao and Number of teachers of Swaziland?
Your response must be concise. -5289. In the year 2006, what is the difference between the Number of teachers of Mexico and Number of teachers of Pakistan?
Make the answer very short. 9.34e+04. In the year 2006, what is the difference between the Number of teachers of Mexico and Number of teachers of Swaziland?
Provide a succinct answer. 5.14e+05. In the year 2006, what is the difference between the Number of teachers in Pakistan and Number of teachers in Swaziland?
Provide a short and direct response. 4.21e+05. In the year 2007, what is the difference between the Number of teachers in Macao and Number of teachers in Mexico?
Ensure brevity in your answer.  -5.21e+05. In the year 2007, what is the difference between the Number of teachers of Macao and Number of teachers of Pakistan?
Make the answer very short. -4.48e+05. In the year 2007, what is the difference between the Number of teachers of Macao and Number of teachers of Swaziland?
Offer a terse response. -5551. In the year 2007, what is the difference between the Number of teachers in Mexico and Number of teachers in Pakistan?
Keep it short and to the point. 7.27e+04. In the year 2007, what is the difference between the Number of teachers in Mexico and Number of teachers in Swaziland?
Make the answer very short. 5.16e+05. In the year 2007, what is the difference between the Number of teachers in Pakistan and Number of teachers in Swaziland?
Your answer should be very brief. 4.43e+05. In the year 2009, what is the difference between the Number of teachers in Macao and Number of teachers in Mexico?
Your answer should be compact. -5.27e+05. In the year 2009, what is the difference between the Number of teachers in Macao and Number of teachers in Pakistan?
Make the answer very short. -4.64e+05. In the year 2009, what is the difference between the Number of teachers in Macao and Number of teachers in Swaziland?
Give a very brief answer. -5725. In the year 2009, what is the difference between the Number of teachers in Mexico and Number of teachers in Pakistan?
Provide a short and direct response. 6.32e+04. In the year 2009, what is the difference between the Number of teachers in Mexico and Number of teachers in Swaziland?
Provide a short and direct response. 5.21e+05. In the year 2009, what is the difference between the Number of teachers of Pakistan and Number of teachers of Swaziland?
Offer a terse response. 4.58e+05. In the year 2010, what is the difference between the Number of teachers of Macao and Number of teachers of Mexico?
Ensure brevity in your answer.  -5.28e+05. In the year 2010, what is the difference between the Number of teachers of Macao and Number of teachers of Pakistan?
Ensure brevity in your answer.  -4.62e+05. In the year 2010, what is the difference between the Number of teachers in Macao and Number of teachers in Swaziland?
Make the answer very short. -5886. In the year 2010, what is the difference between the Number of teachers of Mexico and Number of teachers of Pakistan?
Provide a short and direct response. 6.59e+04. In the year 2010, what is the difference between the Number of teachers of Mexico and Number of teachers of Swaziland?
Provide a succinct answer. 5.22e+05. In the year 2010, what is the difference between the Number of teachers of Pakistan and Number of teachers of Swaziland?
Your answer should be compact. 4.56e+05. What is the ratio of the Number of teachers in Macao in 2002 to that in 2003?
Keep it short and to the point. 1. What is the ratio of the Number of teachers of Mexico in 2002 to that in 2003?
Offer a terse response. 0.99. What is the ratio of the Number of teachers of Pakistan in 2002 to that in 2003?
Offer a terse response. 0.95. What is the ratio of the Number of teachers of Swaziland in 2002 to that in 2003?
Provide a succinct answer. 1.01. What is the ratio of the Number of teachers in Macao in 2002 to that in 2004?
Ensure brevity in your answer.  0.99. What is the ratio of the Number of teachers in Mexico in 2002 to that in 2004?
Offer a terse response. 1.06. What is the ratio of the Number of teachers in Pakistan in 2002 to that in 2004?
Your answer should be very brief. 0.96. What is the ratio of the Number of teachers in Swaziland in 2002 to that in 2004?
Offer a very short reply. 1. What is the ratio of the Number of teachers of Macao in 2002 to that in 2005?
Offer a terse response. 1. What is the ratio of the Number of teachers in Mexico in 2002 to that in 2005?
Make the answer very short. 1.06. What is the ratio of the Number of teachers in Pakistan in 2002 to that in 2005?
Provide a short and direct response. 0.92. What is the ratio of the Number of teachers in Swaziland in 2002 to that in 2005?
Keep it short and to the point. 1. What is the ratio of the Number of teachers of Macao in 2002 to that in 2006?
Provide a succinct answer. 1. What is the ratio of the Number of teachers of Mexico in 2002 to that in 2006?
Give a very brief answer. 1.06. What is the ratio of the Number of teachers of Pakistan in 2002 to that in 2006?
Offer a terse response. 0.97. What is the ratio of the Number of teachers of Swaziland in 2002 to that in 2006?
Provide a short and direct response. 0.97. What is the ratio of the Number of teachers of Macao in 2002 to that in 2007?
Provide a short and direct response. 1. What is the ratio of the Number of teachers in Mexico in 2002 to that in 2007?
Give a very brief answer. 1.06. What is the ratio of the Number of teachers of Pakistan in 2002 to that in 2007?
Give a very brief answer. 0.92. What is the ratio of the Number of teachers of Swaziland in 2002 to that in 2007?
Offer a terse response. 0.94. What is the ratio of the Number of teachers in Macao in 2002 to that in 2009?
Your response must be concise. 1.02. What is the ratio of the Number of teachers in Mexico in 2002 to that in 2009?
Make the answer very short. 1.05. What is the ratio of the Number of teachers in Pakistan in 2002 to that in 2009?
Offer a terse response. 0.89. What is the ratio of the Number of teachers in Swaziland in 2002 to that in 2009?
Your answer should be compact. 0.92. What is the ratio of the Number of teachers of Macao in 2002 to that in 2010?
Make the answer very short. 1.02. What is the ratio of the Number of teachers in Mexico in 2002 to that in 2010?
Ensure brevity in your answer.  1.04. What is the ratio of the Number of teachers of Pakistan in 2002 to that in 2010?
Offer a terse response. 0.89. What is the ratio of the Number of teachers in Swaziland in 2002 to that in 2010?
Give a very brief answer. 0.9. What is the ratio of the Number of teachers of Mexico in 2003 to that in 2004?
Your response must be concise. 1.07. What is the ratio of the Number of teachers in Pakistan in 2003 to that in 2004?
Give a very brief answer. 1. What is the ratio of the Number of teachers in Swaziland in 2003 to that in 2004?
Provide a succinct answer. 0.99. What is the ratio of the Number of teachers of Mexico in 2003 to that in 2005?
Your response must be concise. 1.07. What is the ratio of the Number of teachers of Swaziland in 2003 to that in 2005?
Keep it short and to the point. 0.99. What is the ratio of the Number of teachers in Mexico in 2003 to that in 2006?
Offer a terse response. 1.07. What is the ratio of the Number of teachers of Pakistan in 2003 to that in 2006?
Your answer should be very brief. 1.01. What is the ratio of the Number of teachers of Swaziland in 2003 to that in 2006?
Ensure brevity in your answer.  0.97. What is the ratio of the Number of teachers of Mexico in 2003 to that in 2007?
Give a very brief answer. 1.07. What is the ratio of the Number of teachers in Pakistan in 2003 to that in 2007?
Make the answer very short. 0.96. What is the ratio of the Number of teachers of Swaziland in 2003 to that in 2007?
Provide a succinct answer. 0.93. What is the ratio of the Number of teachers of Macao in 2003 to that in 2009?
Your response must be concise. 1.02. What is the ratio of the Number of teachers of Mexico in 2003 to that in 2009?
Make the answer very short. 1.05. What is the ratio of the Number of teachers in Pakistan in 2003 to that in 2009?
Offer a terse response. 0.93. What is the ratio of the Number of teachers of Swaziland in 2003 to that in 2009?
Your answer should be very brief. 0.91. What is the ratio of the Number of teachers in Macao in 2003 to that in 2010?
Your response must be concise. 1.02. What is the ratio of the Number of teachers of Mexico in 2003 to that in 2010?
Keep it short and to the point. 1.05. What is the ratio of the Number of teachers of Pakistan in 2003 to that in 2010?
Offer a terse response. 0.93. What is the ratio of the Number of teachers in Swaziland in 2003 to that in 2010?
Give a very brief answer. 0.9. What is the ratio of the Number of teachers of Macao in 2004 to that in 2005?
Ensure brevity in your answer.  1.01. What is the ratio of the Number of teachers of Pakistan in 2004 to that in 2005?
Ensure brevity in your answer.  0.96. What is the ratio of the Number of teachers of Macao in 2004 to that in 2006?
Offer a terse response. 1.01. What is the ratio of the Number of teachers of Pakistan in 2004 to that in 2006?
Your answer should be very brief. 1.01. What is the ratio of the Number of teachers of Swaziland in 2004 to that in 2006?
Make the answer very short. 0.98. What is the ratio of the Number of teachers in Macao in 2004 to that in 2007?
Provide a short and direct response. 1.01. What is the ratio of the Number of teachers of Mexico in 2004 to that in 2007?
Your answer should be very brief. 0.99. What is the ratio of the Number of teachers of Pakistan in 2004 to that in 2007?
Make the answer very short. 0.96. What is the ratio of the Number of teachers of Swaziland in 2004 to that in 2007?
Provide a short and direct response. 0.94. What is the ratio of the Number of teachers of Macao in 2004 to that in 2009?
Provide a succinct answer. 1.03. What is the ratio of the Number of teachers in Mexico in 2004 to that in 2009?
Offer a very short reply. 0.98. What is the ratio of the Number of teachers in Pakistan in 2004 to that in 2009?
Provide a succinct answer. 0.93. What is the ratio of the Number of teachers in Swaziland in 2004 to that in 2009?
Give a very brief answer. 0.92. What is the ratio of the Number of teachers in Macao in 2004 to that in 2010?
Give a very brief answer. 1.03. What is the ratio of the Number of teachers of Mexico in 2004 to that in 2010?
Give a very brief answer. 0.98. What is the ratio of the Number of teachers in Pakistan in 2004 to that in 2010?
Your answer should be compact. 0.93. What is the ratio of the Number of teachers of Swaziland in 2004 to that in 2010?
Your response must be concise. 0.91. What is the ratio of the Number of teachers in Pakistan in 2005 to that in 2006?
Provide a short and direct response. 1.05. What is the ratio of the Number of teachers in Swaziland in 2005 to that in 2006?
Your response must be concise. 0.98. What is the ratio of the Number of teachers of Macao in 2005 to that in 2007?
Give a very brief answer. 0.99. What is the ratio of the Number of teachers of Swaziland in 2005 to that in 2007?
Give a very brief answer. 0.94. What is the ratio of the Number of teachers of Macao in 2005 to that in 2009?
Provide a short and direct response. 1.02. What is the ratio of the Number of teachers of Mexico in 2005 to that in 2009?
Ensure brevity in your answer.  0.98. What is the ratio of the Number of teachers of Pakistan in 2005 to that in 2009?
Your response must be concise. 0.97. What is the ratio of the Number of teachers of Swaziland in 2005 to that in 2009?
Offer a very short reply. 0.92. What is the ratio of the Number of teachers in Macao in 2005 to that in 2010?
Provide a succinct answer. 1.02. What is the ratio of the Number of teachers in Mexico in 2005 to that in 2010?
Provide a short and direct response. 0.98. What is the ratio of the Number of teachers of Pakistan in 2005 to that in 2010?
Give a very brief answer. 0.97. What is the ratio of the Number of teachers of Swaziland in 2005 to that in 2010?
Offer a terse response. 0.9. What is the ratio of the Number of teachers of Macao in 2006 to that in 2007?
Ensure brevity in your answer.  1. What is the ratio of the Number of teachers of Pakistan in 2006 to that in 2007?
Provide a short and direct response. 0.95. What is the ratio of the Number of teachers in Swaziland in 2006 to that in 2007?
Keep it short and to the point. 0.96. What is the ratio of the Number of teachers in Macao in 2006 to that in 2009?
Provide a succinct answer. 1.02. What is the ratio of the Number of teachers of Mexico in 2006 to that in 2009?
Offer a very short reply. 0.99. What is the ratio of the Number of teachers in Pakistan in 2006 to that in 2009?
Offer a very short reply. 0.92. What is the ratio of the Number of teachers in Swaziland in 2006 to that in 2009?
Make the answer very short. 0.94. What is the ratio of the Number of teachers in Macao in 2006 to that in 2010?
Provide a short and direct response. 1.03. What is the ratio of the Number of teachers of Mexico in 2006 to that in 2010?
Provide a short and direct response. 0.98. What is the ratio of the Number of teachers in Pakistan in 2006 to that in 2010?
Provide a succinct answer. 0.92. What is the ratio of the Number of teachers of Swaziland in 2006 to that in 2010?
Provide a short and direct response. 0.93. What is the ratio of the Number of teachers in Macao in 2007 to that in 2009?
Provide a succinct answer. 1.02. What is the ratio of the Number of teachers in Pakistan in 2007 to that in 2009?
Your answer should be compact. 0.97. What is the ratio of the Number of teachers of Swaziland in 2007 to that in 2009?
Provide a succinct answer. 0.98. What is the ratio of the Number of teachers of Macao in 2007 to that in 2010?
Offer a very short reply. 1.03. What is the ratio of the Number of teachers in Pakistan in 2007 to that in 2010?
Keep it short and to the point. 0.97. What is the ratio of the Number of teachers in Swaziland in 2007 to that in 2010?
Provide a succinct answer. 0.96. What is the ratio of the Number of teachers in Macao in 2009 to that in 2010?
Ensure brevity in your answer.  1.01. What is the ratio of the Number of teachers of Mexico in 2009 to that in 2010?
Your answer should be compact. 1. What is the ratio of the Number of teachers in Swaziland in 2009 to that in 2010?
Make the answer very short. 0.98. What is the difference between the highest and the second highest Number of teachers of Mexico?
Keep it short and to the point. 4869. What is the difference between the highest and the second highest Number of teachers of Pakistan?
Provide a succinct answer. 1660. What is the difference between the highest and the second highest Number of teachers of Swaziland?
Provide a succinct answer. 153. What is the difference between the highest and the lowest Number of teachers of Macao?
Provide a short and direct response. 55. What is the difference between the highest and the lowest Number of teachers in Mexico?
Your answer should be very brief. 3.82e+04. What is the difference between the highest and the lowest Number of teachers of Pakistan?
Provide a succinct answer. 5.14e+04. What is the difference between the highest and the lowest Number of teachers of Swaziland?
Provide a succinct answer. 783. 